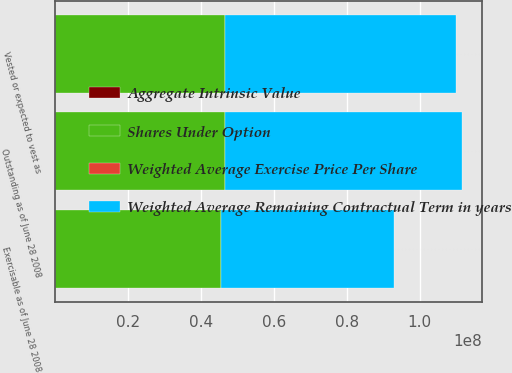Convert chart. <chart><loc_0><loc_0><loc_500><loc_500><stacked_bar_chart><ecel><fcel>Outstanding as of June 28 2008<fcel>Vested or expected to vest as<fcel>Exercisable as of June 28 2008<nl><fcel>Weighted Average Remaining Contractual Term in years<fcel>6.52443e+07<fcel>6.36086e+07<fcel>4.7411e+07<nl><fcel>Aggregate Intrinsic Value<fcel>30.05<fcel>29.99<fcel>29.14<nl><fcel>Weighted Average Exercise Price Per Share<fcel>4.14<fcel>4.13<fcel>3.8<nl><fcel>Shares Under Option<fcel>4.6439e+07<fcel>4.6436e+07<fcel>4.5499e+07<nl></chart> 